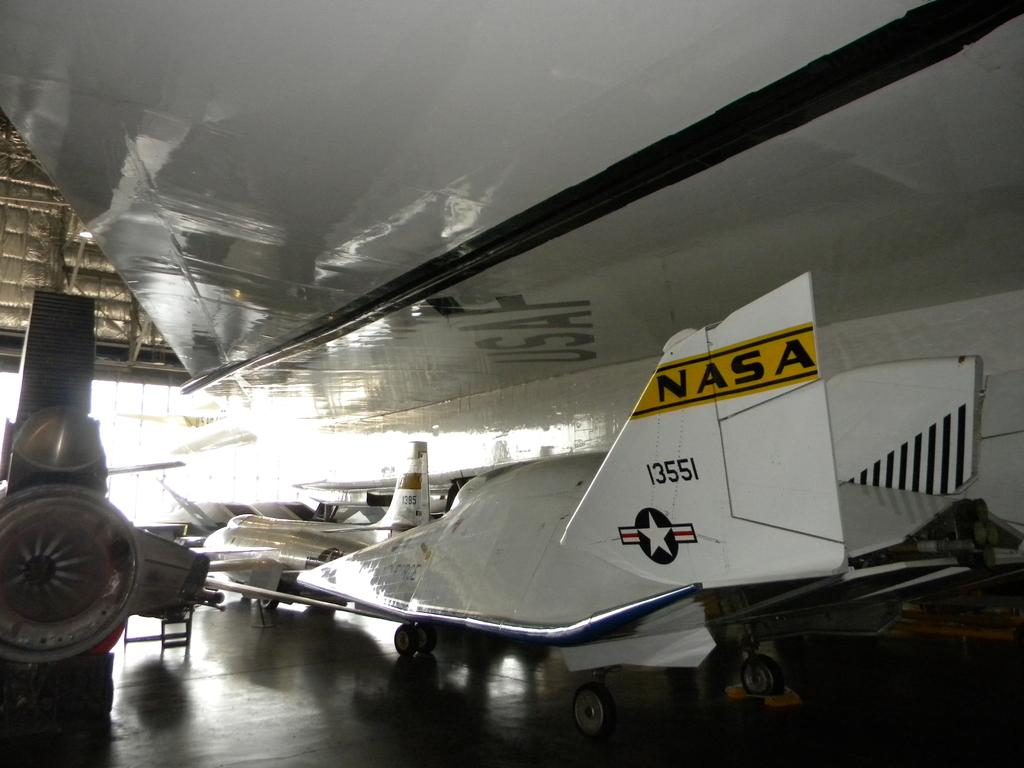<image>
Render a clear and concise summary of the photo. a NASA flying ship is in a building with other machines 